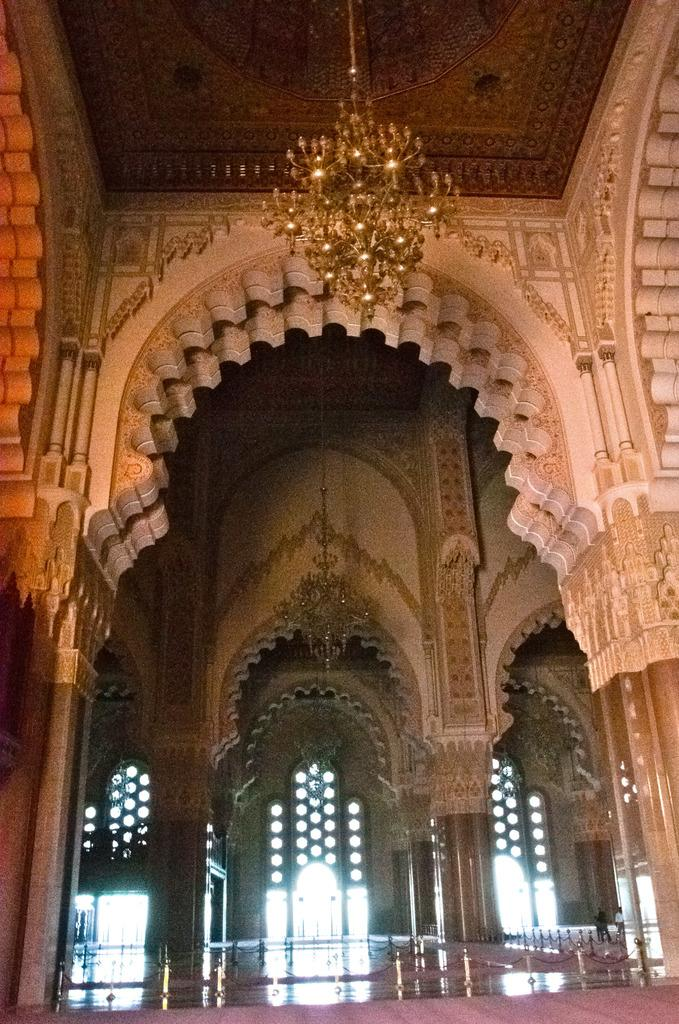What type of building is shown in the image? The image shows the inner view of a palace. Can you describe any specific features of the palace? There is a chandelier on the roof in the image. What type of honey can be seen dripping from the chandelier in the image? There is no honey present in the image; it only shows a chandelier on the roof of the palace. 